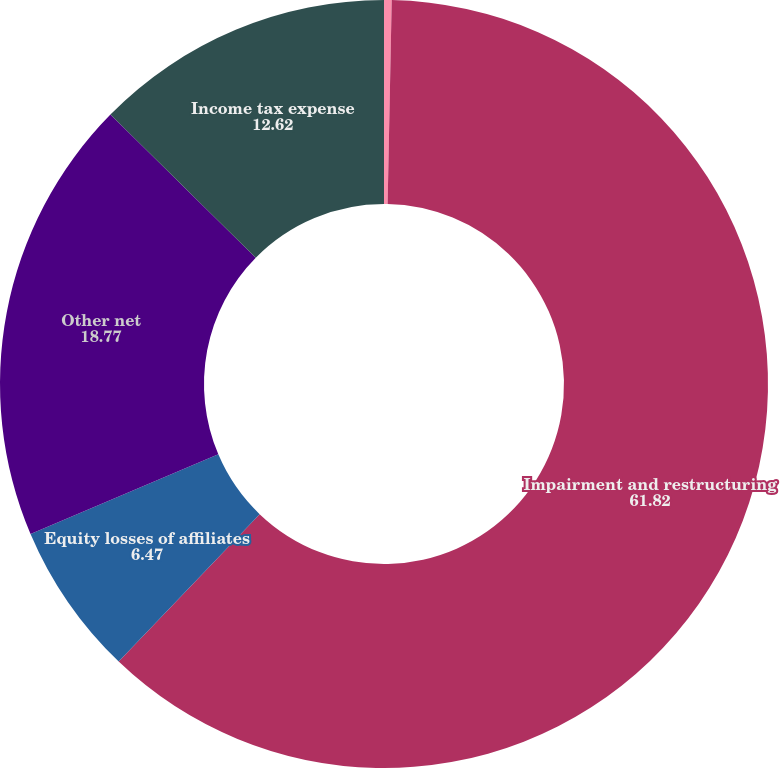<chart> <loc_0><loc_0><loc_500><loc_500><pie_chart><fcel>Total Revenues<fcel>Impairment and restructuring<fcel>Equity losses of affiliates<fcel>Other net<fcel>Income tax expense<nl><fcel>0.32%<fcel>61.82%<fcel>6.47%<fcel>18.77%<fcel>12.62%<nl></chart> 